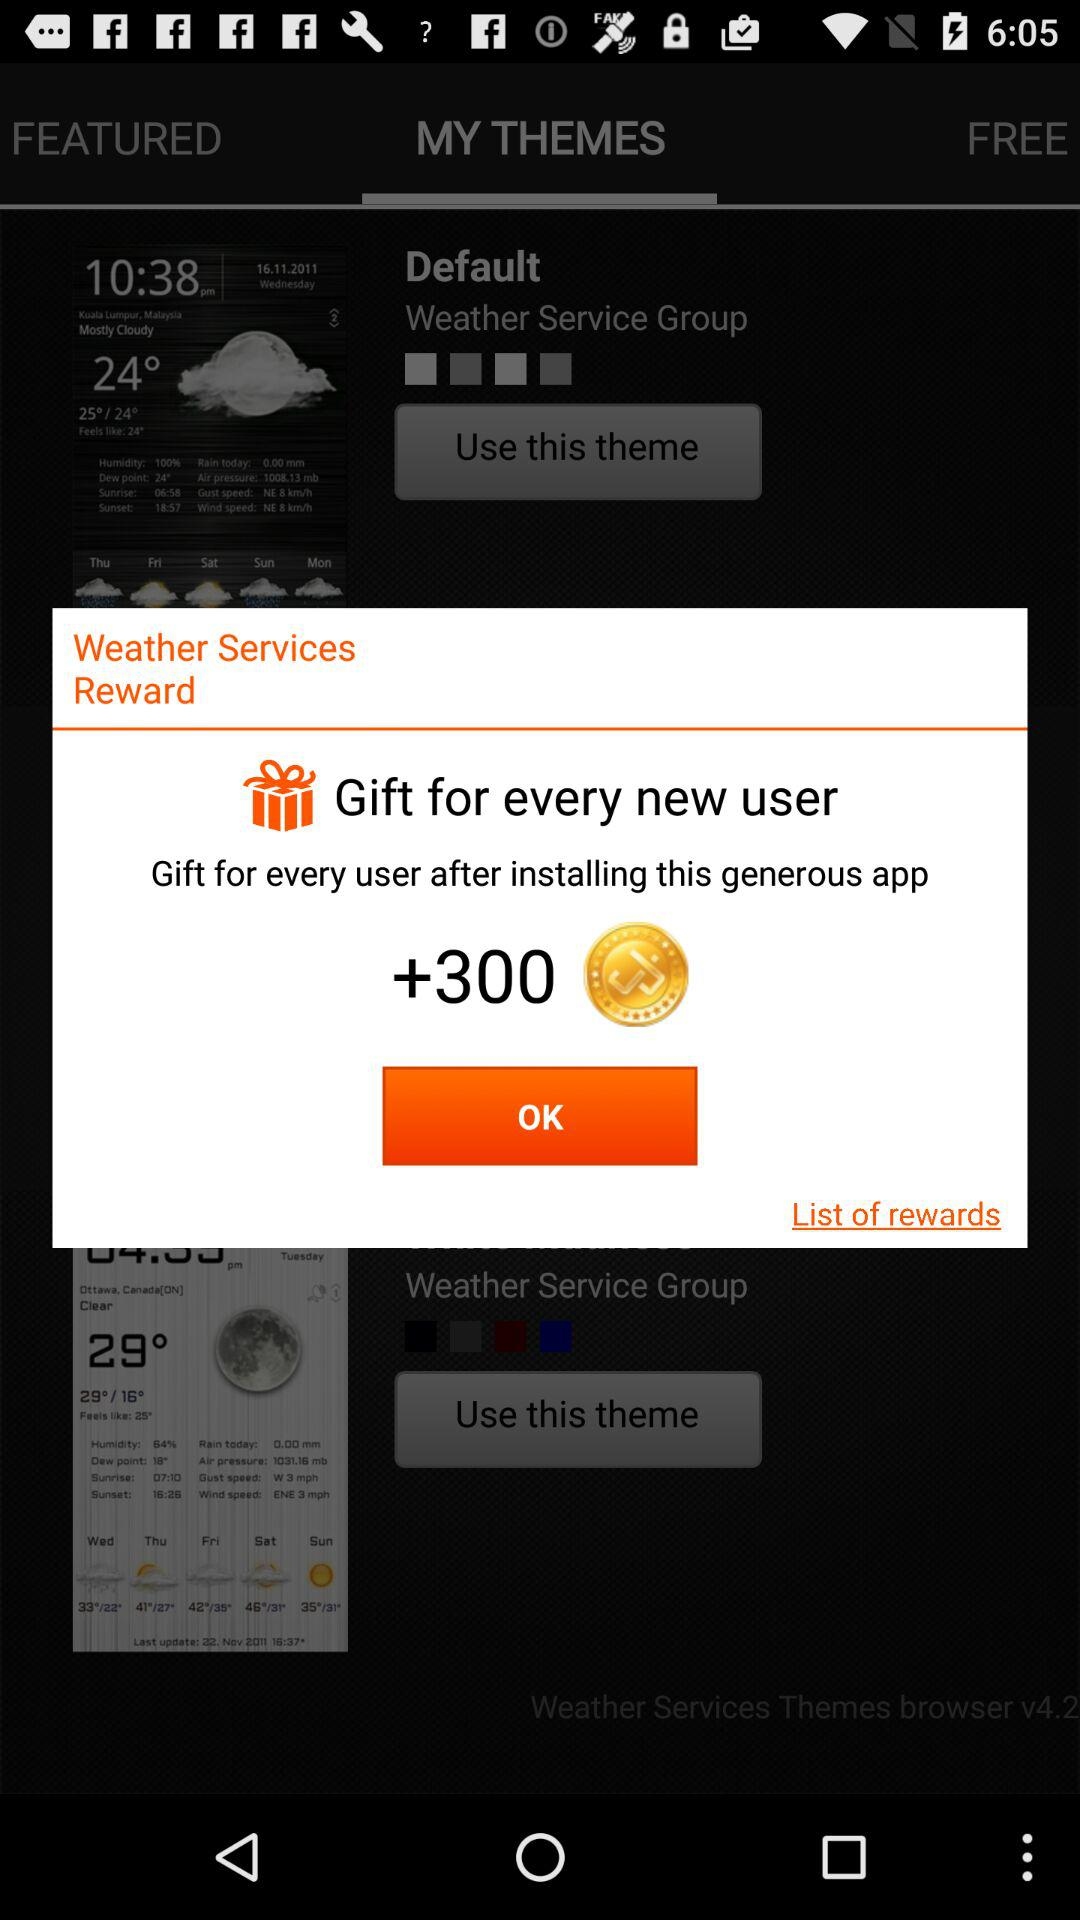How many more coins do I get if I click OK?
Answer the question using a single word or phrase. 300 